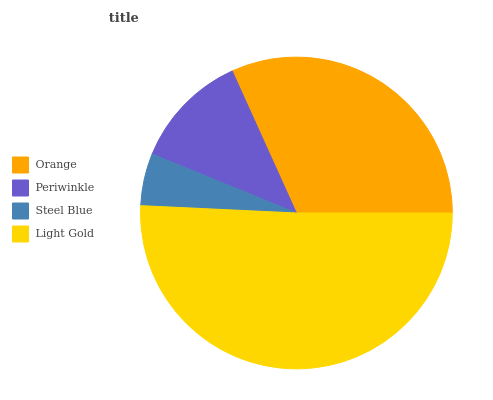Is Steel Blue the minimum?
Answer yes or no. Yes. Is Light Gold the maximum?
Answer yes or no. Yes. Is Periwinkle the minimum?
Answer yes or no. No. Is Periwinkle the maximum?
Answer yes or no. No. Is Orange greater than Periwinkle?
Answer yes or no. Yes. Is Periwinkle less than Orange?
Answer yes or no. Yes. Is Periwinkle greater than Orange?
Answer yes or no. No. Is Orange less than Periwinkle?
Answer yes or no. No. Is Orange the high median?
Answer yes or no. Yes. Is Periwinkle the low median?
Answer yes or no. Yes. Is Light Gold the high median?
Answer yes or no. No. Is Light Gold the low median?
Answer yes or no. No. 